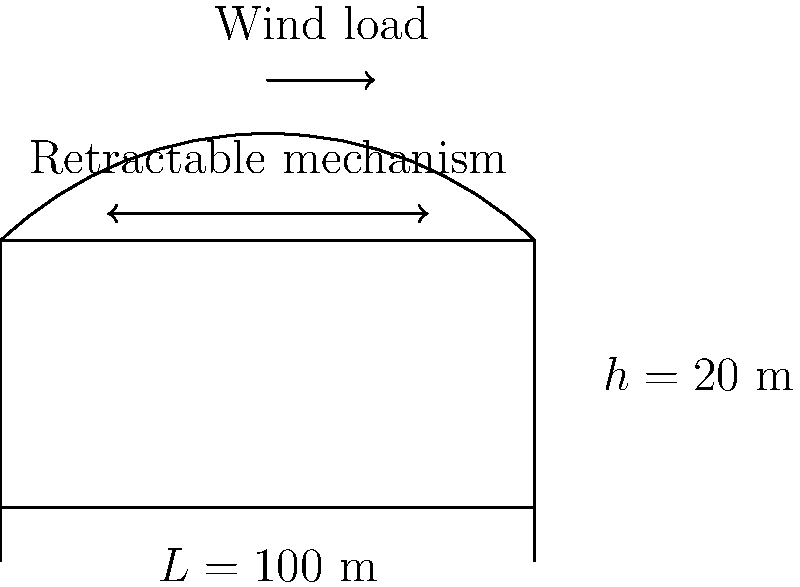As a rising tennis star, you're excited about the new multi-purpose sports complex being built in Melbourne. The complex features a retractable roof spanning 100 meters. If the maximum wind load on the roof is 2 kN/m² and the roof weighs 0.5 kN/m², what is the total factored load per linear meter on the main support beam, assuming a load factor of 1.4 for dead load and 1.6 for wind load? Let's approach this step-by-step:

1) First, we need to identify the loads:
   - Dead load (roof weight): 0.5 kN/m²
   - Wind load: 2 kN/m²

2) Apply the load factors:
   - Factored dead load = 0.5 kN/m² × 1.4 = 0.7 kN/m²
   - Factored wind load = 2 kN/m² × 1.6 = 3.2 kN/m²

3) Sum up the factored loads:
   Total factored load = 0.7 kN/m² + 3.2 kN/m² = 3.9 kN/m²

4) The question asks for load per linear meter on the main support beam. To get this, we need to multiply the total load per square meter by the span of the roof:
   
   Load per linear meter = 3.9 kN/m² × 100 m = 390 kN/m

This represents the total factored load that the main support beam must carry per linear meter of its length.
Answer: 390 kN/m 